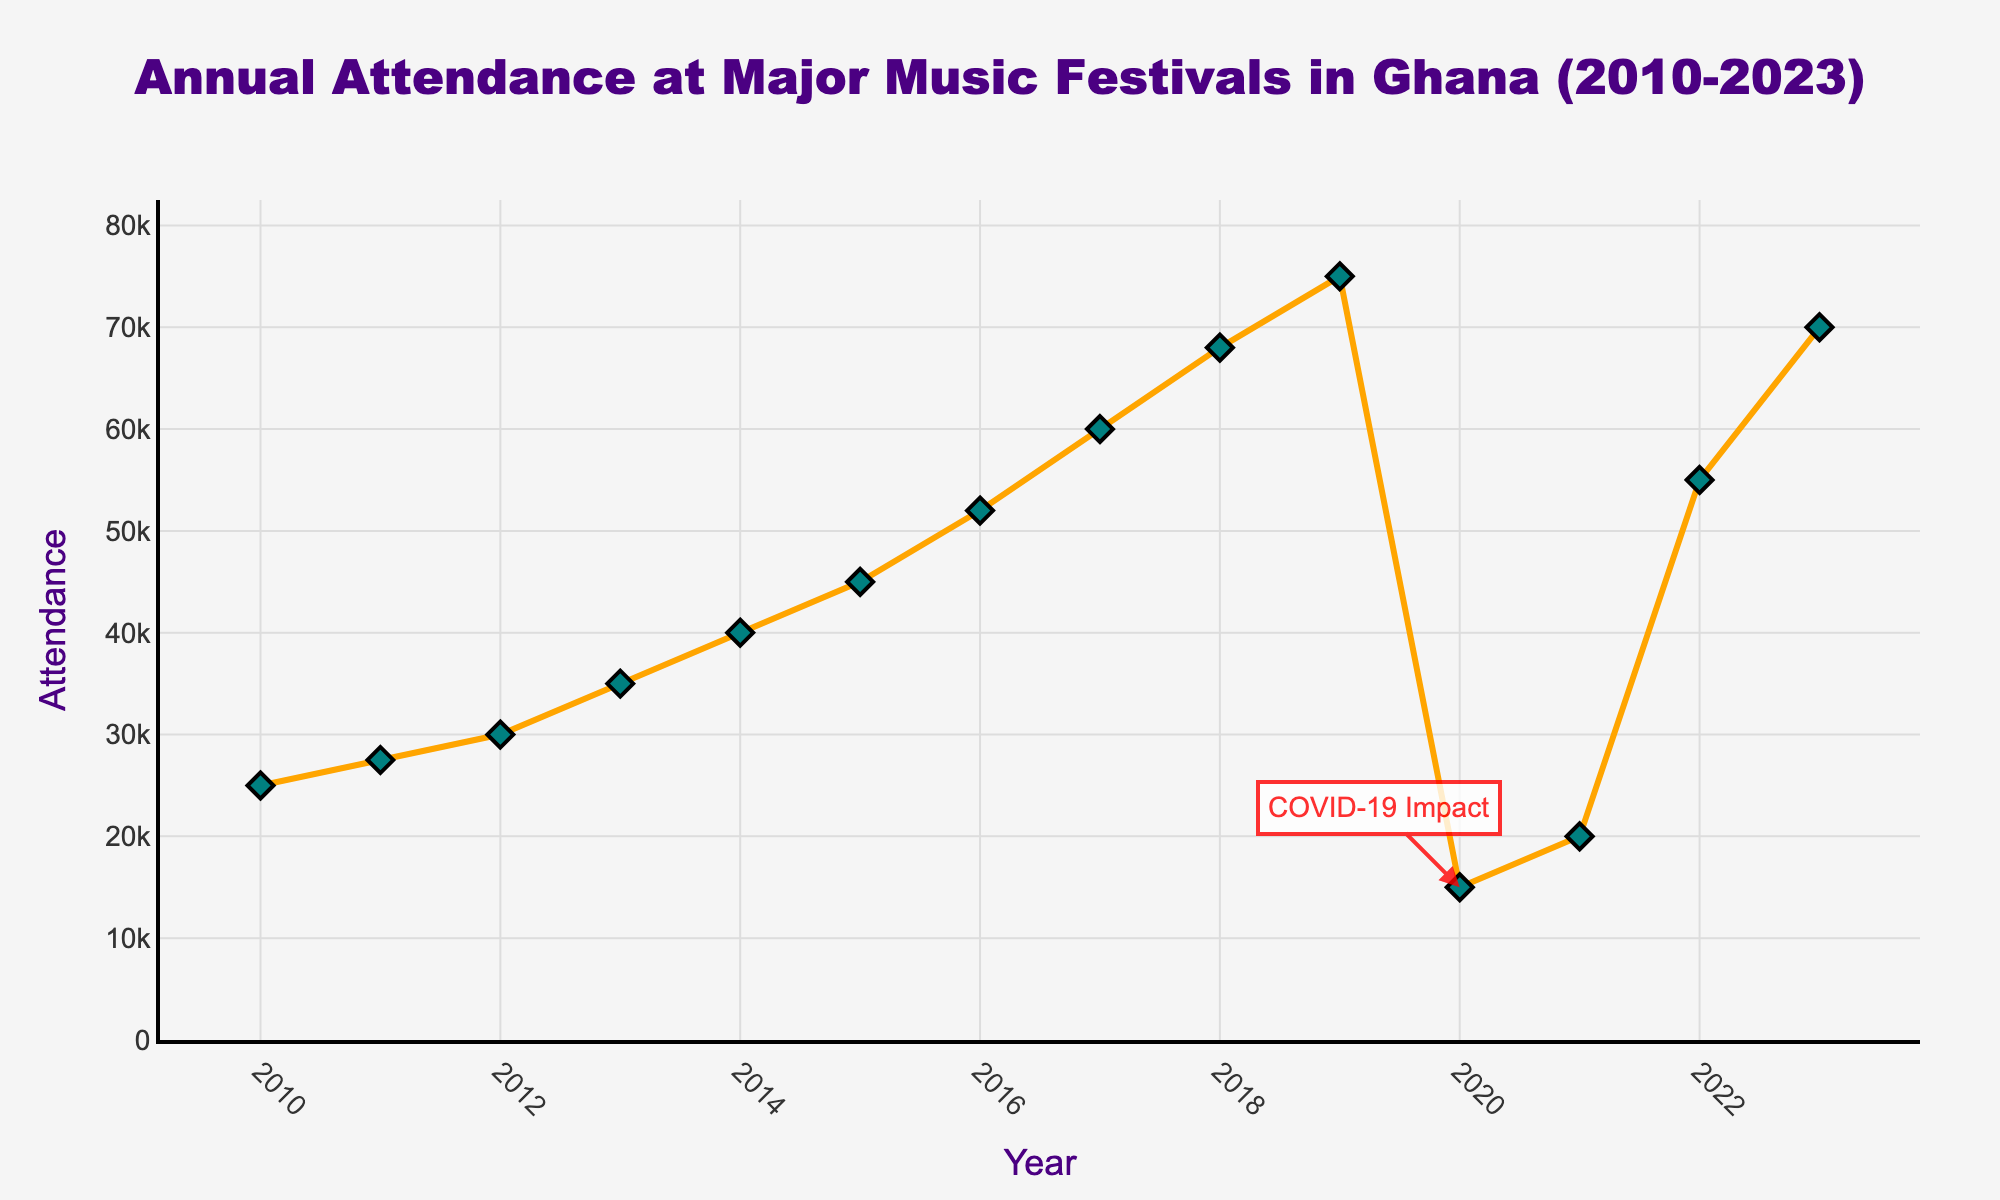Which year had the highest attendance? Look at the highest point on the line graph and refer to the corresponding year on the x-axis. For this question, the highest data point is in 2023.
Answer: 2023 How did attendance change from 2019 to 2020? Observe the difference in the height of the markers for 2019 and 2020. The attendance dropped significantly from 75,000 in 2019 to 15,000 in 2020.
Answer: Decreased What is the average attendance from 2010 to 2019? Sum the attendance from 2010 to 2019 and divide by the number of years in this span. (25000 + 27500 + 30000 + 35000 + 40000 + 45000 + 52000 + 60000 + 68000 + 75000) / 10 = 45750
Answer: 45,750 By how much did the attendance increase from 2011 to 2017? Subtract the attendance in 2011 from the attendance in 2017. 60,000 (2017) - 27,500 (2011) = 32,500
Answer: 32,500 Which year experienced the most substantial decrease in attendance? Identify the year where the lines between two consecutive years show the steepest downward slope. The largest drop is from 2019 to 2020.
Answer: 2020 Between which two consecutive years did the attendance increase the most? Compare the vertical distance between consecutive data points. The most significant increase is from 2021 to 2022, from 20,000 to 55,000.
Answer: 2021 to 2022 What is the median attendance from 2010 to 2023? Arrange all the attendance figures from least to greatest and find the middle value. With an even number of data points (14 years), the median will be the average of the 7th and 8th values. (45000 + 52000) / 2 = 48,500
Answer: 48,500 How does the attendance in 2023 compare to the attendance in 2018? Compare the height of the markers for 2023 and 2018. 2023's attendance (70,000) is higher than 2018's (68,000).
Answer: Higher What visual annotation is present in the year 2020, and what does it signify? There is a red annotation in 2020 that says "COVID-19 Impact", indicating the pandemic's effect on festival attendance that year.
Answer: COVID-19 Impact What is the difference in attendance between the first and last year in the data? Subtract the attendance in 2010 from the attendance in 2023. 70,000 (2023) - 25,000 (2010) = 45,000
Answer: 45,000 